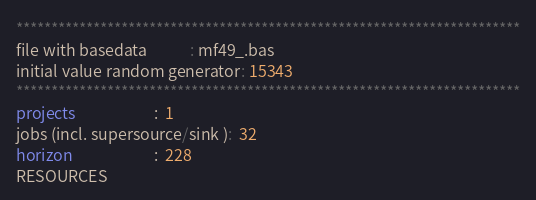Convert code to text. <code><loc_0><loc_0><loc_500><loc_500><_ObjectiveC_>************************************************************************
file with basedata            : mf49_.bas
initial value random generator: 15343
************************************************************************
projects                      :  1
jobs (incl. supersource/sink ):  32
horizon                       :  228
RESOURCES</code> 